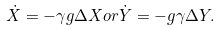<formula> <loc_0><loc_0><loc_500><loc_500>\dot { X } = - \gamma g \Delta X o r \dot { Y } = - g \gamma \Delta Y .</formula> 